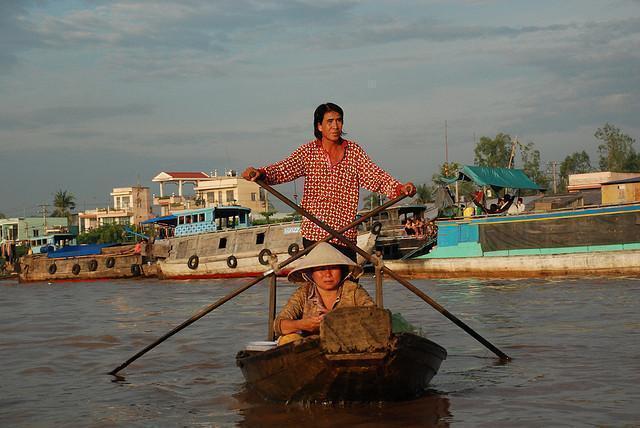The person in the front of the boat is wearing a hat from which continent?
Pick the right solution, then justify: 'Answer: answer
Rationale: rationale.'
Options: Australia, asia, antarctica, africa. Answer: asia.
Rationale: The man is wearing a conical or rice hat popular in places such as vietnam or china. What shape are the oars forming?
Select the correct answer and articulate reasoning with the following format: 'Answer: answer
Rationale: rationale.'
Options: Cross, star, circle, square. Answer: cross.
Rationale: A man is staning on a boat. he has the oars crisscrossed making an x. 